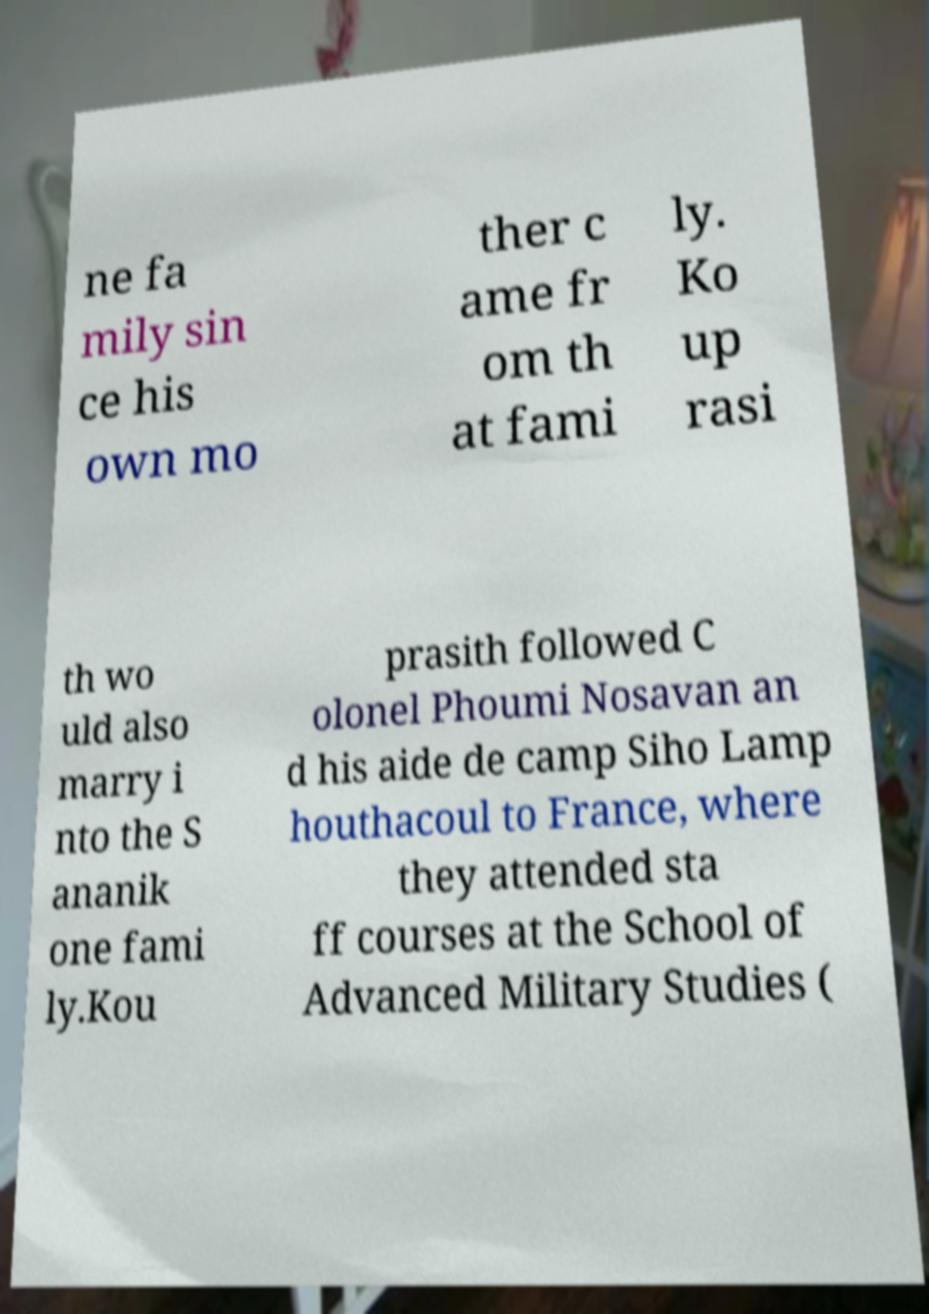What messages or text are displayed in this image? I need them in a readable, typed format. ne fa mily sin ce his own mo ther c ame fr om th at fami ly. Ko up rasi th wo uld also marry i nto the S ananik one fami ly.Kou prasith followed C olonel Phoumi Nosavan an d his aide de camp Siho Lamp houthacoul to France, where they attended sta ff courses at the School of Advanced Military Studies ( 